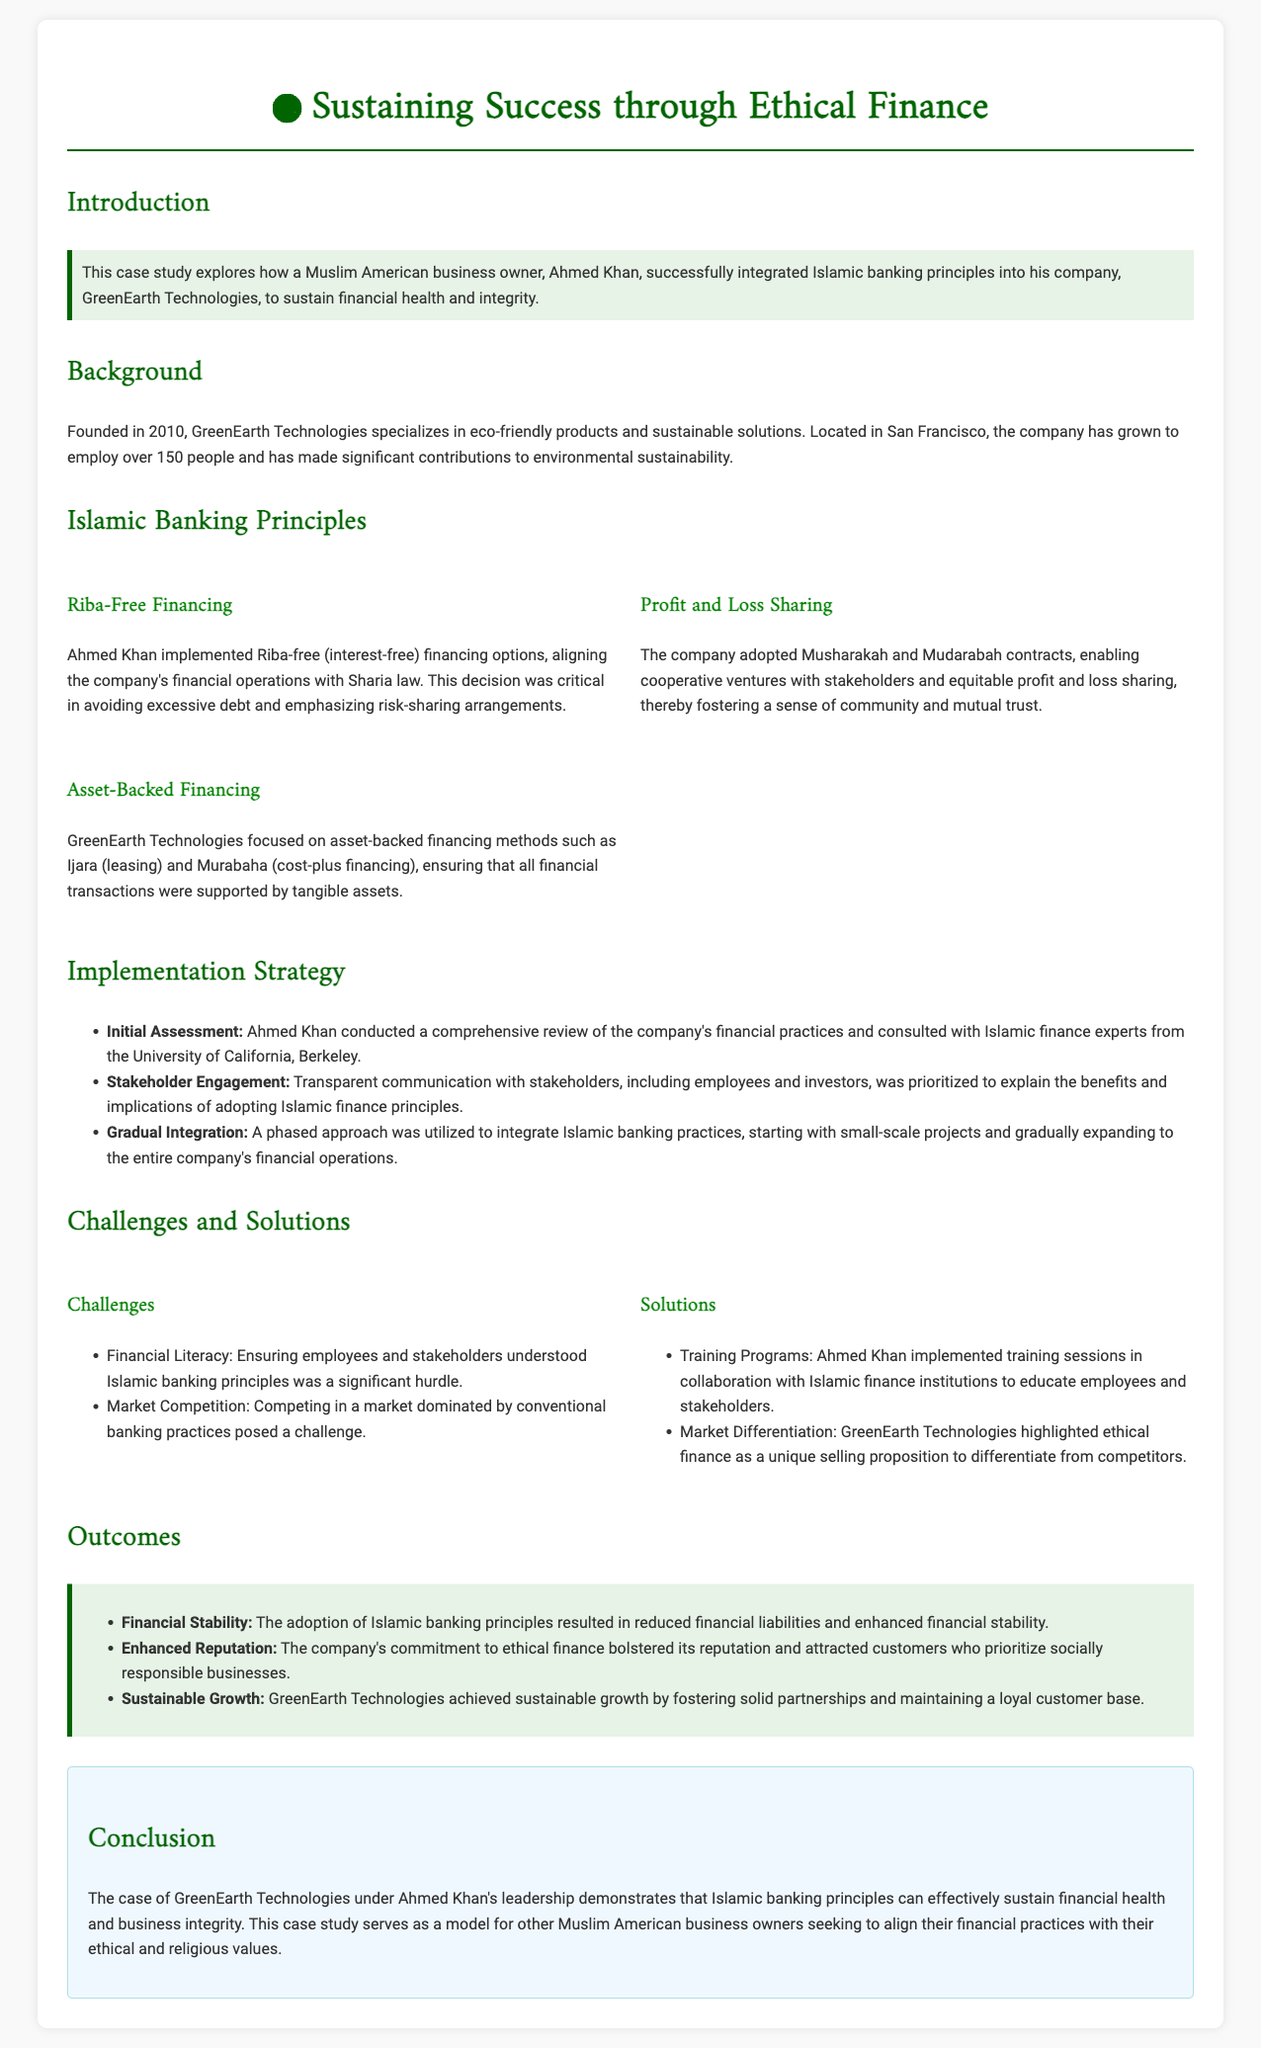What is the name of the business owner featured in the case study? The case study focuses on Ahmed Khan, the owner of GreenEarth Technologies.
Answer: Ahmed Khan What year was GreenEarth Technologies founded? The foundation year of GreenEarth Technologies is mentioned as 2010 in the document.
Answer: 2010 What is the primary industry of GreenEarth Technologies? The company specializes in eco-friendly products and sustainable solutions.
Answer: Eco-friendly products What financing method does the company emphasize according to Islamic principles? The case study mentions Riba-free financing as a critical part of their financial operations.
Answer: Riba-free financing What type of training program was implemented by Ahmed Khan? He initiated training sessions in collaboration with Islamic finance institutions to educate stakeholders.
Answer: Training programs What was a significant challenge faced by GreenEarth Technologies? Ensuring employees understood Islamic banking principles was a notable challenge.
Answer: Financial Literacy How many employees does GreenEarth Technologies have? The company employs over 150 people.
Answer: Over 150 What was the impact on the company's reputation after adopting Islamic banking principles? The commitment to ethical finance bolstered the company's reputation.
Answer: Enhanced Reputation What kind of approach did Ahmed Khan take for integrating Islamic banking practices? A phased approach was utilized starting with small-scale projects.
Answer: Gradual Integration 